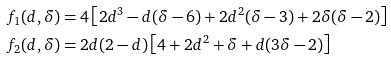Convert formula to latex. <formula><loc_0><loc_0><loc_500><loc_500>f _ { 1 } ( d , \delta ) & = 4 \left [ 2 d ^ { 3 } - d ( \delta - 6 ) + 2 d ^ { 2 } ( \delta - 3 ) + 2 \delta ( \delta - 2 ) \right ] \\ f _ { 2 } ( d , \delta ) & = 2 d ( 2 - d ) \left [ 4 + 2 d ^ { 2 } + \delta + d ( 3 \delta - 2 ) \right ]</formula> 